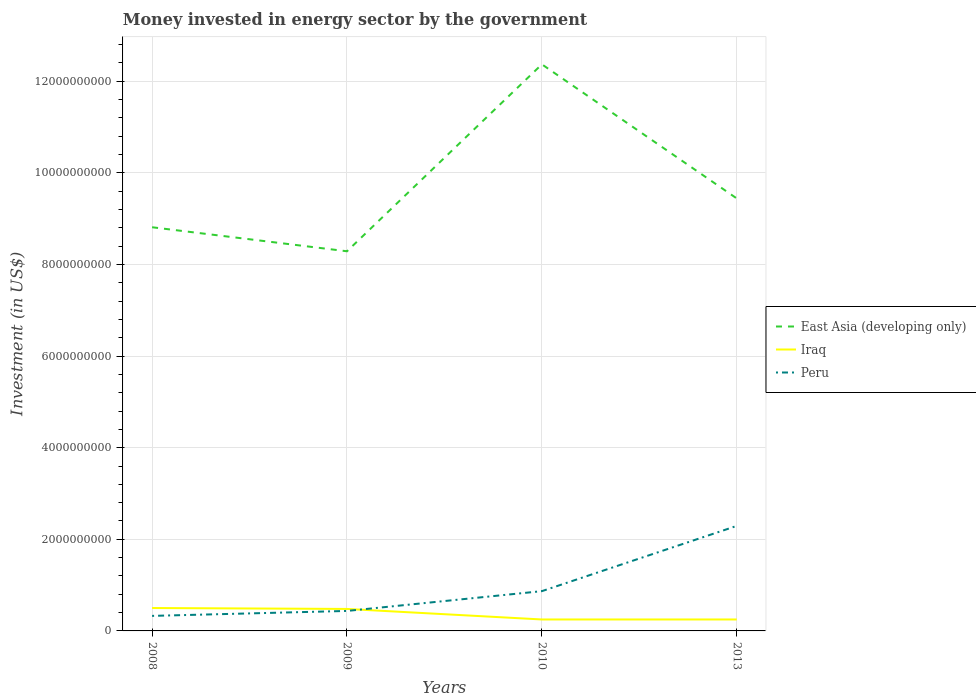How many different coloured lines are there?
Your response must be concise. 3. Across all years, what is the maximum money spent in energy sector in Iraq?
Give a very brief answer. 2.50e+08. What is the total money spent in energy sector in Iraq in the graph?
Keep it short and to the point. 2.50e+08. What is the difference between the highest and the second highest money spent in energy sector in Iraq?
Offer a very short reply. 2.50e+08. What is the difference between the highest and the lowest money spent in energy sector in Peru?
Provide a succinct answer. 1. Is the money spent in energy sector in Peru strictly greater than the money spent in energy sector in Iraq over the years?
Give a very brief answer. No. How many lines are there?
Give a very brief answer. 3. How many years are there in the graph?
Your answer should be very brief. 4. What is the difference between two consecutive major ticks on the Y-axis?
Keep it short and to the point. 2.00e+09. Are the values on the major ticks of Y-axis written in scientific E-notation?
Keep it short and to the point. No. How many legend labels are there?
Your response must be concise. 3. What is the title of the graph?
Provide a succinct answer. Money invested in energy sector by the government. Does "Bahamas" appear as one of the legend labels in the graph?
Your answer should be compact. No. What is the label or title of the Y-axis?
Your response must be concise. Investment (in US$). What is the Investment (in US$) in East Asia (developing only) in 2008?
Your response must be concise. 8.81e+09. What is the Investment (in US$) in Iraq in 2008?
Your answer should be compact. 5.00e+08. What is the Investment (in US$) of Peru in 2008?
Give a very brief answer. 3.28e+08. What is the Investment (in US$) of East Asia (developing only) in 2009?
Your answer should be compact. 8.29e+09. What is the Investment (in US$) of Iraq in 2009?
Your answer should be compact. 4.80e+08. What is the Investment (in US$) in Peru in 2009?
Your answer should be very brief. 4.36e+08. What is the Investment (in US$) in East Asia (developing only) in 2010?
Give a very brief answer. 1.24e+1. What is the Investment (in US$) in Iraq in 2010?
Your answer should be compact. 2.50e+08. What is the Investment (in US$) in Peru in 2010?
Keep it short and to the point. 8.68e+08. What is the Investment (in US$) of East Asia (developing only) in 2013?
Keep it short and to the point. 9.44e+09. What is the Investment (in US$) of Iraq in 2013?
Your answer should be compact. 2.50e+08. What is the Investment (in US$) in Peru in 2013?
Give a very brief answer. 2.29e+09. Across all years, what is the maximum Investment (in US$) of East Asia (developing only)?
Make the answer very short. 1.24e+1. Across all years, what is the maximum Investment (in US$) in Peru?
Your answer should be very brief. 2.29e+09. Across all years, what is the minimum Investment (in US$) in East Asia (developing only)?
Your response must be concise. 8.29e+09. Across all years, what is the minimum Investment (in US$) of Iraq?
Offer a terse response. 2.50e+08. Across all years, what is the minimum Investment (in US$) in Peru?
Provide a succinct answer. 3.28e+08. What is the total Investment (in US$) in East Asia (developing only) in the graph?
Offer a very short reply. 3.89e+1. What is the total Investment (in US$) of Iraq in the graph?
Offer a terse response. 1.48e+09. What is the total Investment (in US$) of Peru in the graph?
Make the answer very short. 3.92e+09. What is the difference between the Investment (in US$) in East Asia (developing only) in 2008 and that in 2009?
Your answer should be compact. 5.25e+08. What is the difference between the Investment (in US$) of Iraq in 2008 and that in 2009?
Your answer should be compact. 2.00e+07. What is the difference between the Investment (in US$) in Peru in 2008 and that in 2009?
Your response must be concise. -1.08e+08. What is the difference between the Investment (in US$) of East Asia (developing only) in 2008 and that in 2010?
Your response must be concise. -3.56e+09. What is the difference between the Investment (in US$) of Iraq in 2008 and that in 2010?
Give a very brief answer. 2.50e+08. What is the difference between the Investment (in US$) in Peru in 2008 and that in 2010?
Offer a very short reply. -5.40e+08. What is the difference between the Investment (in US$) in East Asia (developing only) in 2008 and that in 2013?
Offer a terse response. -6.29e+08. What is the difference between the Investment (in US$) of Iraq in 2008 and that in 2013?
Offer a very short reply. 2.50e+08. What is the difference between the Investment (in US$) in Peru in 2008 and that in 2013?
Give a very brief answer. -1.96e+09. What is the difference between the Investment (in US$) in East Asia (developing only) in 2009 and that in 2010?
Provide a succinct answer. -4.08e+09. What is the difference between the Investment (in US$) of Iraq in 2009 and that in 2010?
Keep it short and to the point. 2.30e+08. What is the difference between the Investment (in US$) of Peru in 2009 and that in 2010?
Keep it short and to the point. -4.32e+08. What is the difference between the Investment (in US$) of East Asia (developing only) in 2009 and that in 2013?
Offer a very short reply. -1.15e+09. What is the difference between the Investment (in US$) in Iraq in 2009 and that in 2013?
Make the answer very short. 2.30e+08. What is the difference between the Investment (in US$) of Peru in 2009 and that in 2013?
Keep it short and to the point. -1.86e+09. What is the difference between the Investment (in US$) of East Asia (developing only) in 2010 and that in 2013?
Offer a very short reply. 2.93e+09. What is the difference between the Investment (in US$) of Peru in 2010 and that in 2013?
Make the answer very short. -1.42e+09. What is the difference between the Investment (in US$) of East Asia (developing only) in 2008 and the Investment (in US$) of Iraq in 2009?
Your response must be concise. 8.33e+09. What is the difference between the Investment (in US$) of East Asia (developing only) in 2008 and the Investment (in US$) of Peru in 2009?
Provide a short and direct response. 8.38e+09. What is the difference between the Investment (in US$) in Iraq in 2008 and the Investment (in US$) in Peru in 2009?
Provide a succinct answer. 6.37e+07. What is the difference between the Investment (in US$) in East Asia (developing only) in 2008 and the Investment (in US$) in Iraq in 2010?
Offer a very short reply. 8.56e+09. What is the difference between the Investment (in US$) in East Asia (developing only) in 2008 and the Investment (in US$) in Peru in 2010?
Provide a succinct answer. 7.94e+09. What is the difference between the Investment (in US$) of Iraq in 2008 and the Investment (in US$) of Peru in 2010?
Provide a short and direct response. -3.68e+08. What is the difference between the Investment (in US$) in East Asia (developing only) in 2008 and the Investment (in US$) in Iraq in 2013?
Your answer should be very brief. 8.56e+09. What is the difference between the Investment (in US$) of East Asia (developing only) in 2008 and the Investment (in US$) of Peru in 2013?
Offer a very short reply. 6.52e+09. What is the difference between the Investment (in US$) of Iraq in 2008 and the Investment (in US$) of Peru in 2013?
Make the answer very short. -1.79e+09. What is the difference between the Investment (in US$) in East Asia (developing only) in 2009 and the Investment (in US$) in Iraq in 2010?
Your answer should be very brief. 8.04e+09. What is the difference between the Investment (in US$) of East Asia (developing only) in 2009 and the Investment (in US$) of Peru in 2010?
Offer a very short reply. 7.42e+09. What is the difference between the Investment (in US$) in Iraq in 2009 and the Investment (in US$) in Peru in 2010?
Provide a short and direct response. -3.88e+08. What is the difference between the Investment (in US$) of East Asia (developing only) in 2009 and the Investment (in US$) of Iraq in 2013?
Make the answer very short. 8.04e+09. What is the difference between the Investment (in US$) of East Asia (developing only) in 2009 and the Investment (in US$) of Peru in 2013?
Give a very brief answer. 6.00e+09. What is the difference between the Investment (in US$) in Iraq in 2009 and the Investment (in US$) in Peru in 2013?
Offer a very short reply. -1.81e+09. What is the difference between the Investment (in US$) of East Asia (developing only) in 2010 and the Investment (in US$) of Iraq in 2013?
Your response must be concise. 1.21e+1. What is the difference between the Investment (in US$) of East Asia (developing only) in 2010 and the Investment (in US$) of Peru in 2013?
Offer a very short reply. 1.01e+1. What is the difference between the Investment (in US$) of Iraq in 2010 and the Investment (in US$) of Peru in 2013?
Your answer should be very brief. -2.04e+09. What is the average Investment (in US$) in East Asia (developing only) per year?
Your answer should be very brief. 9.73e+09. What is the average Investment (in US$) in Iraq per year?
Give a very brief answer. 3.70e+08. What is the average Investment (in US$) of Peru per year?
Give a very brief answer. 9.81e+08. In the year 2008, what is the difference between the Investment (in US$) of East Asia (developing only) and Investment (in US$) of Iraq?
Keep it short and to the point. 8.31e+09. In the year 2008, what is the difference between the Investment (in US$) in East Asia (developing only) and Investment (in US$) in Peru?
Your answer should be very brief. 8.48e+09. In the year 2008, what is the difference between the Investment (in US$) in Iraq and Investment (in US$) in Peru?
Ensure brevity in your answer.  1.72e+08. In the year 2009, what is the difference between the Investment (in US$) in East Asia (developing only) and Investment (in US$) in Iraq?
Keep it short and to the point. 7.81e+09. In the year 2009, what is the difference between the Investment (in US$) of East Asia (developing only) and Investment (in US$) of Peru?
Offer a terse response. 7.85e+09. In the year 2009, what is the difference between the Investment (in US$) in Iraq and Investment (in US$) in Peru?
Give a very brief answer. 4.37e+07. In the year 2010, what is the difference between the Investment (in US$) in East Asia (developing only) and Investment (in US$) in Iraq?
Provide a short and direct response. 1.21e+1. In the year 2010, what is the difference between the Investment (in US$) of East Asia (developing only) and Investment (in US$) of Peru?
Ensure brevity in your answer.  1.15e+1. In the year 2010, what is the difference between the Investment (in US$) in Iraq and Investment (in US$) in Peru?
Provide a succinct answer. -6.18e+08. In the year 2013, what is the difference between the Investment (in US$) of East Asia (developing only) and Investment (in US$) of Iraq?
Keep it short and to the point. 9.19e+09. In the year 2013, what is the difference between the Investment (in US$) of East Asia (developing only) and Investment (in US$) of Peru?
Make the answer very short. 7.15e+09. In the year 2013, what is the difference between the Investment (in US$) of Iraq and Investment (in US$) of Peru?
Your answer should be compact. -2.04e+09. What is the ratio of the Investment (in US$) in East Asia (developing only) in 2008 to that in 2009?
Offer a very short reply. 1.06. What is the ratio of the Investment (in US$) in Iraq in 2008 to that in 2009?
Your answer should be very brief. 1.04. What is the ratio of the Investment (in US$) of Peru in 2008 to that in 2009?
Offer a very short reply. 0.75. What is the ratio of the Investment (in US$) of East Asia (developing only) in 2008 to that in 2010?
Your answer should be compact. 0.71. What is the ratio of the Investment (in US$) in Peru in 2008 to that in 2010?
Your answer should be compact. 0.38. What is the ratio of the Investment (in US$) in East Asia (developing only) in 2008 to that in 2013?
Your answer should be very brief. 0.93. What is the ratio of the Investment (in US$) of Iraq in 2008 to that in 2013?
Your answer should be compact. 2. What is the ratio of the Investment (in US$) in Peru in 2008 to that in 2013?
Offer a very short reply. 0.14. What is the ratio of the Investment (in US$) in East Asia (developing only) in 2009 to that in 2010?
Make the answer very short. 0.67. What is the ratio of the Investment (in US$) of Iraq in 2009 to that in 2010?
Your answer should be compact. 1.92. What is the ratio of the Investment (in US$) of Peru in 2009 to that in 2010?
Offer a terse response. 0.5. What is the ratio of the Investment (in US$) in East Asia (developing only) in 2009 to that in 2013?
Give a very brief answer. 0.88. What is the ratio of the Investment (in US$) in Iraq in 2009 to that in 2013?
Your answer should be compact. 1.92. What is the ratio of the Investment (in US$) in Peru in 2009 to that in 2013?
Provide a short and direct response. 0.19. What is the ratio of the Investment (in US$) in East Asia (developing only) in 2010 to that in 2013?
Your answer should be compact. 1.31. What is the ratio of the Investment (in US$) of Peru in 2010 to that in 2013?
Offer a very short reply. 0.38. What is the difference between the highest and the second highest Investment (in US$) of East Asia (developing only)?
Provide a succinct answer. 2.93e+09. What is the difference between the highest and the second highest Investment (in US$) of Iraq?
Offer a terse response. 2.00e+07. What is the difference between the highest and the second highest Investment (in US$) of Peru?
Your answer should be compact. 1.42e+09. What is the difference between the highest and the lowest Investment (in US$) in East Asia (developing only)?
Your response must be concise. 4.08e+09. What is the difference between the highest and the lowest Investment (in US$) of Iraq?
Offer a terse response. 2.50e+08. What is the difference between the highest and the lowest Investment (in US$) in Peru?
Provide a succinct answer. 1.96e+09. 